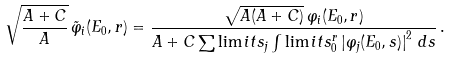Convert formula to latex. <formula><loc_0><loc_0><loc_500><loc_500>\sqrt { \frac { A + C } { A } } \, \tilde { \varphi } _ { i } ( E _ { 0 } , r ) = \frac { \sqrt { A ( A + C ) } \, \varphi _ { i } ( E _ { 0 } , r ) } { A + C \sum \lim i t s _ { j } \int \lim i t s _ { 0 } ^ { r } \left | \varphi _ { j } ( E _ { 0 } , s ) \right | ^ { 2 } \, d s } \, .</formula> 